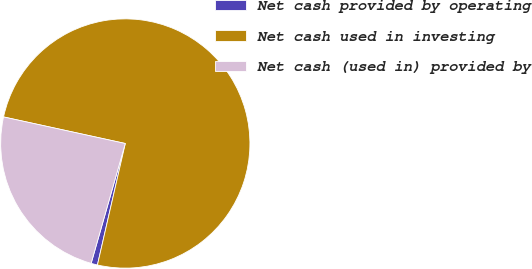Convert chart. <chart><loc_0><loc_0><loc_500><loc_500><pie_chart><fcel>Net cash provided by operating<fcel>Net cash used in investing<fcel>Net cash (used in) provided by<nl><fcel>0.83%<fcel>75.17%<fcel>24.0%<nl></chart> 